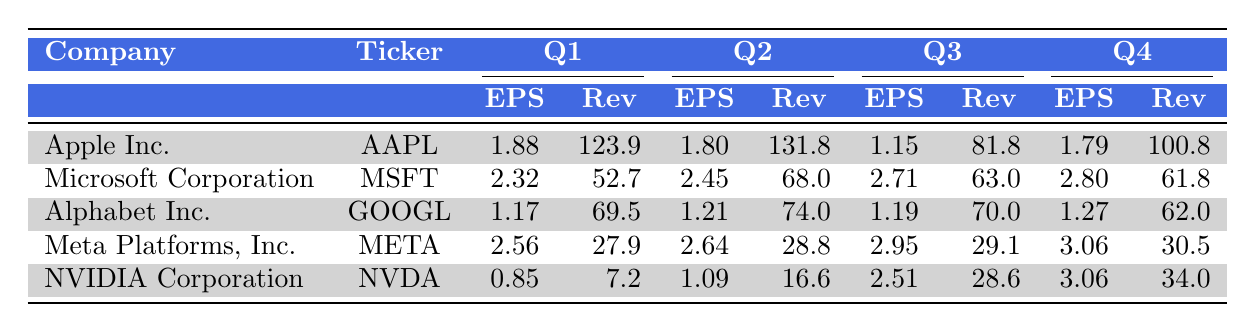What was the total revenue for Microsoft in Q2? The revenue for Microsoft in Q2 is listed as 68.0, so the total revenue for that quarter is 68.0
Answer: 68.0 Which company had the highest earnings per share in Q1? In Q1, Apple Inc. had an EPS of 1.88, Microsoft had 2.32, Alphabet had 1.17, Meta had 2.56, and NVIDIA had 0.85. Comparing these values, Microsoft had the highest EPS at 2.32
Answer: Microsoft Corporation What is the average earnings per share for Apple across all four quarters? To find the average, we need to sum up the EPS for Apple across all quarters: (1.88 + 1.80 + 1.15 + 1.79) = 6.62. Then, we divide by the number of quarters, which is 4: 6.62 / 4 = 1.655
Answer: 1.655 Did Nvidia show an increase in earnings per share from Q1 to Q4? In Q1, NVIDIA had an EPS of 0.85, and in Q4, it had an EPS of 3.06. Since 3.06 is greater than 0.85, this indicates an increase in EPS from Q1 to Q4
Answer: Yes Which company had the lowest revenue in Q2? In Q2, the revenues for the companies are: Apple 131.8, Microsoft 68.0, Alphabet 74.0, Meta 28.8, and NVIDIA 16.6. The lowest revenue is from Meta at 28.8
Answer: Meta Platforms, Inc 